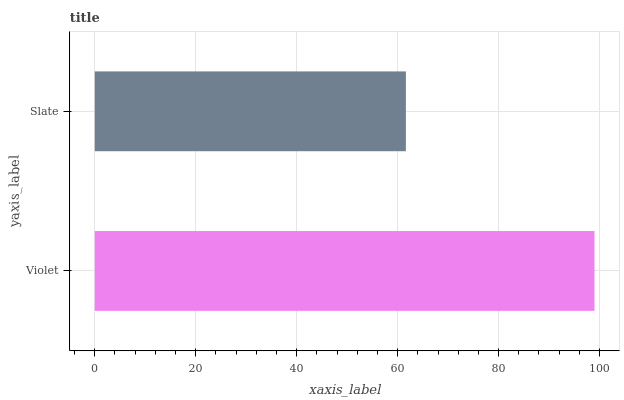Is Slate the minimum?
Answer yes or no. Yes. Is Violet the maximum?
Answer yes or no. Yes. Is Slate the maximum?
Answer yes or no. No. Is Violet greater than Slate?
Answer yes or no. Yes. Is Slate less than Violet?
Answer yes or no. Yes. Is Slate greater than Violet?
Answer yes or no. No. Is Violet less than Slate?
Answer yes or no. No. Is Violet the high median?
Answer yes or no. Yes. Is Slate the low median?
Answer yes or no. Yes. Is Slate the high median?
Answer yes or no. No. Is Violet the low median?
Answer yes or no. No. 